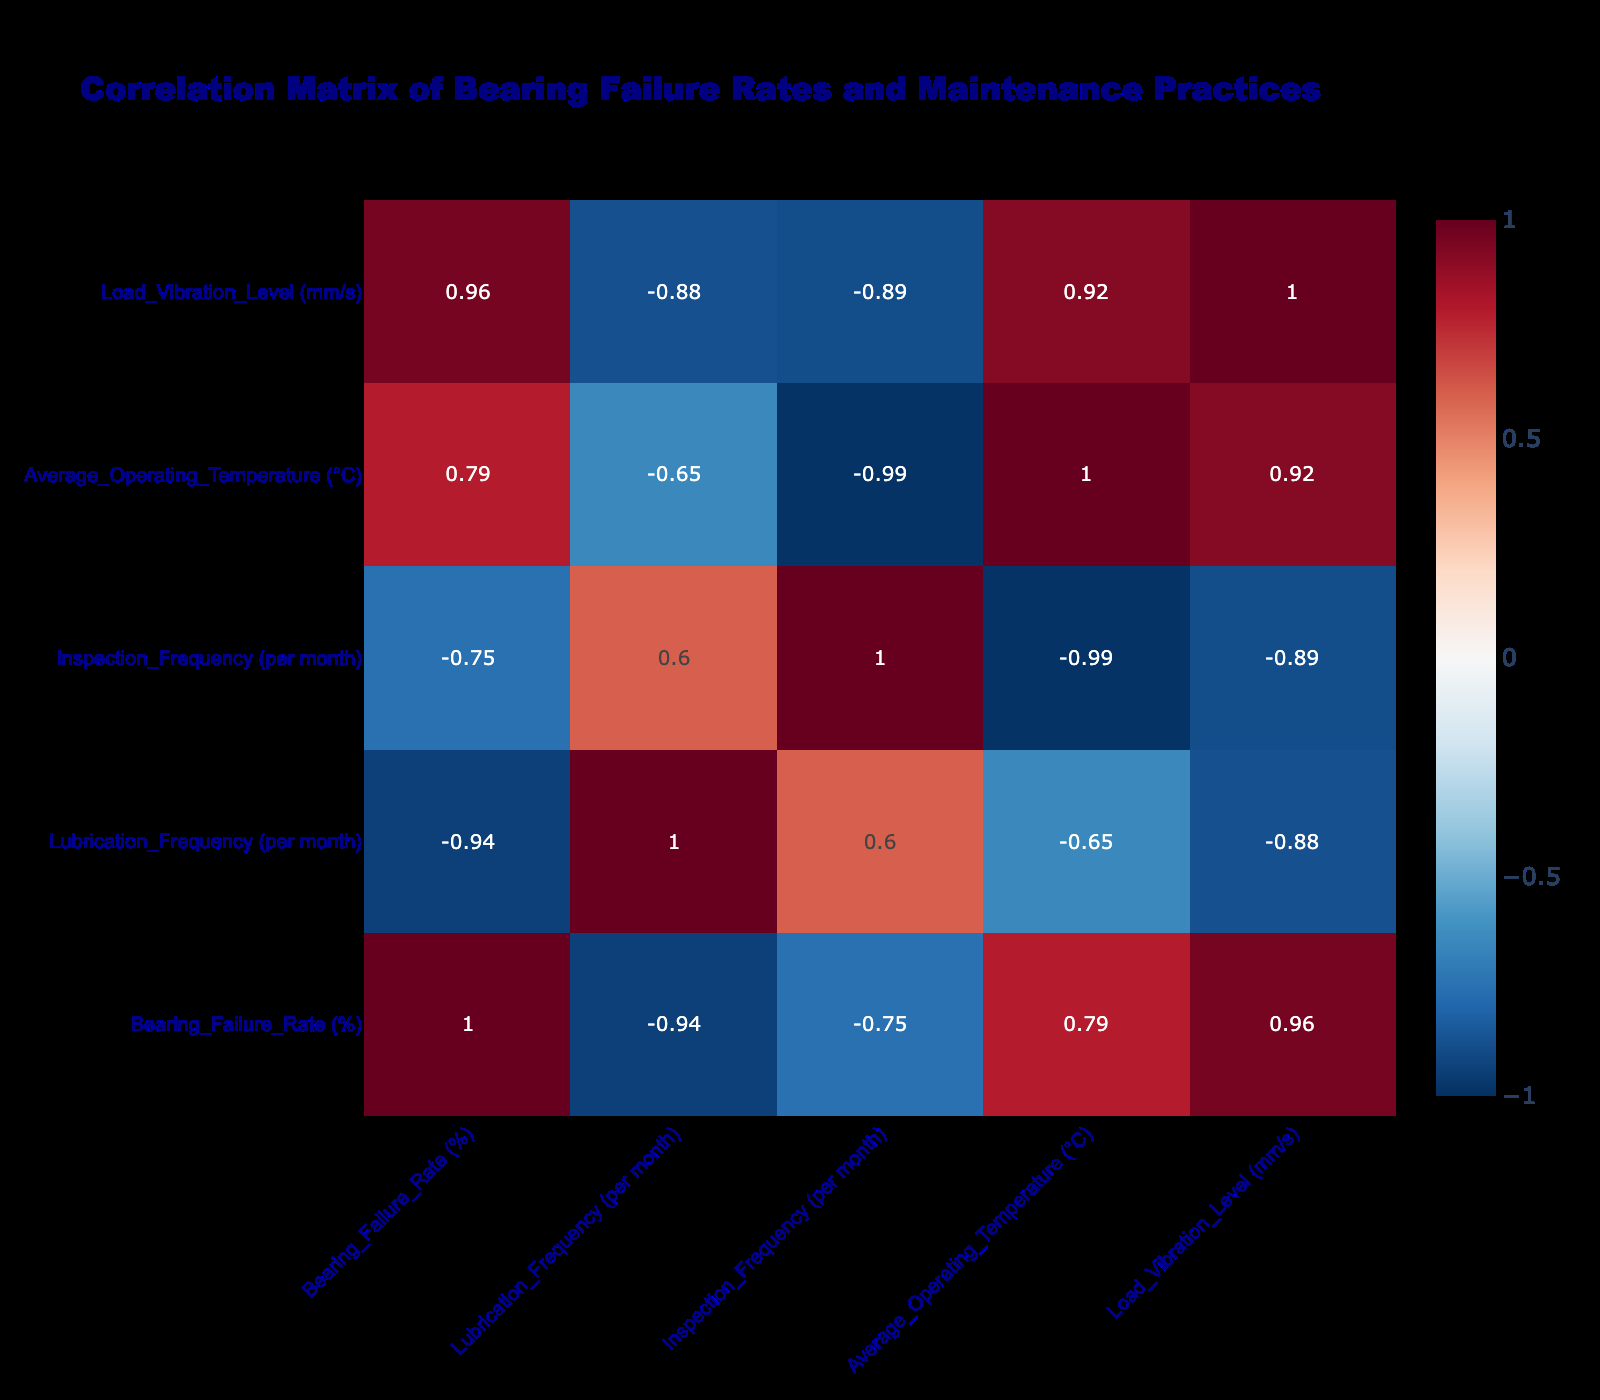What is the bearing failure rate with the reactive maintenance practice? According to the table, the bearing failure rate for the reactive maintenance practice is explicitly listed as 15.0%.
Answer: 15.0% What is the correlation between lubrication frequency and bearing failure rate? To find the correlation between lubrication frequency and bearing failure rate, we refer to the correlation matrix. The value is negative, indicating that as lubrication frequency increases, the bearing failure rate tends to decrease.
Answer: Negative correlation Which maintenance practice has the highest bearing failure rate? The table shows that the unscheduled maintenance practice has the highest bearing failure rate at 20.0%.
Answer: 20.0% What is the average bearing failure rate across all maintenance practices? By adding all the individual bearing failure rates (5.0 + 3.0 + 15.0 + 8.0 + 4.5 + 20.0) and dividing by the number of practices (6), the average bearing failure rate is (55.5 / 6) = 9.25%.
Answer: 9.25% Is the condition-based maintenance practice associated with a lower bearing failure rate compared to the preventive maintenance practice? The condition-based maintenance practice has a failure rate of 8.0%, while the preventive maintenance practice has a failure rate of 5.0%. Thus, condition-based is not lower than preventive.
Answer: No What is the difference in bearing failure rates between the unscheduled and predictive maintenance practices? The unscheduled maintenance practice has a failure rate of 20.0%, and the predictive practice has 3.0%, so the difference is 20.0 - 3.0 = 17.0%.
Answer: 17.0% How often is lubrication done in the maintenance practice with the lowest bearing failure rate? Preventive maintenance has the lowest bearing failure rate at 5.0%, and the lubrication frequency for this practice is 4 times per month.
Answer: 4 Is there a correlation between average operating temperature and bearing failure rate? Referring to the correlation matrix indicates a positive correlation; as the average operating temperature increases, the bearing failure rate tends to increase as well.
Answer: Yes What is the load vibration level for the maintenance practice with the second highest bearing failure rate? The unscheduled maintenance practice has the highest failure rate at 20.0%. The next highest is the reactive practice at 15.0%, which has a load vibration level of 2.5 mm/s.
Answer: 2.5 mm/s 